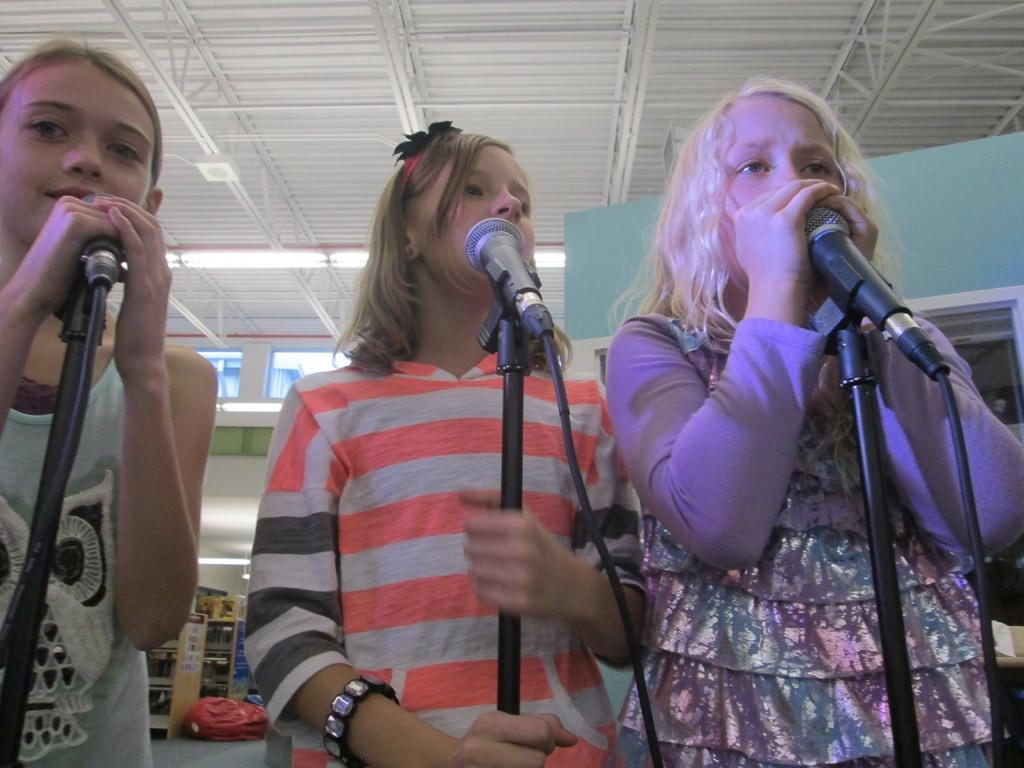Who is present in the image? There are girls in the image. What are the girls holding in the image? The girls are holding microphones. What type of skin condition can be seen on the girls in the image? There is no mention of any skin condition in the image, and the girls' skin is not visible. 